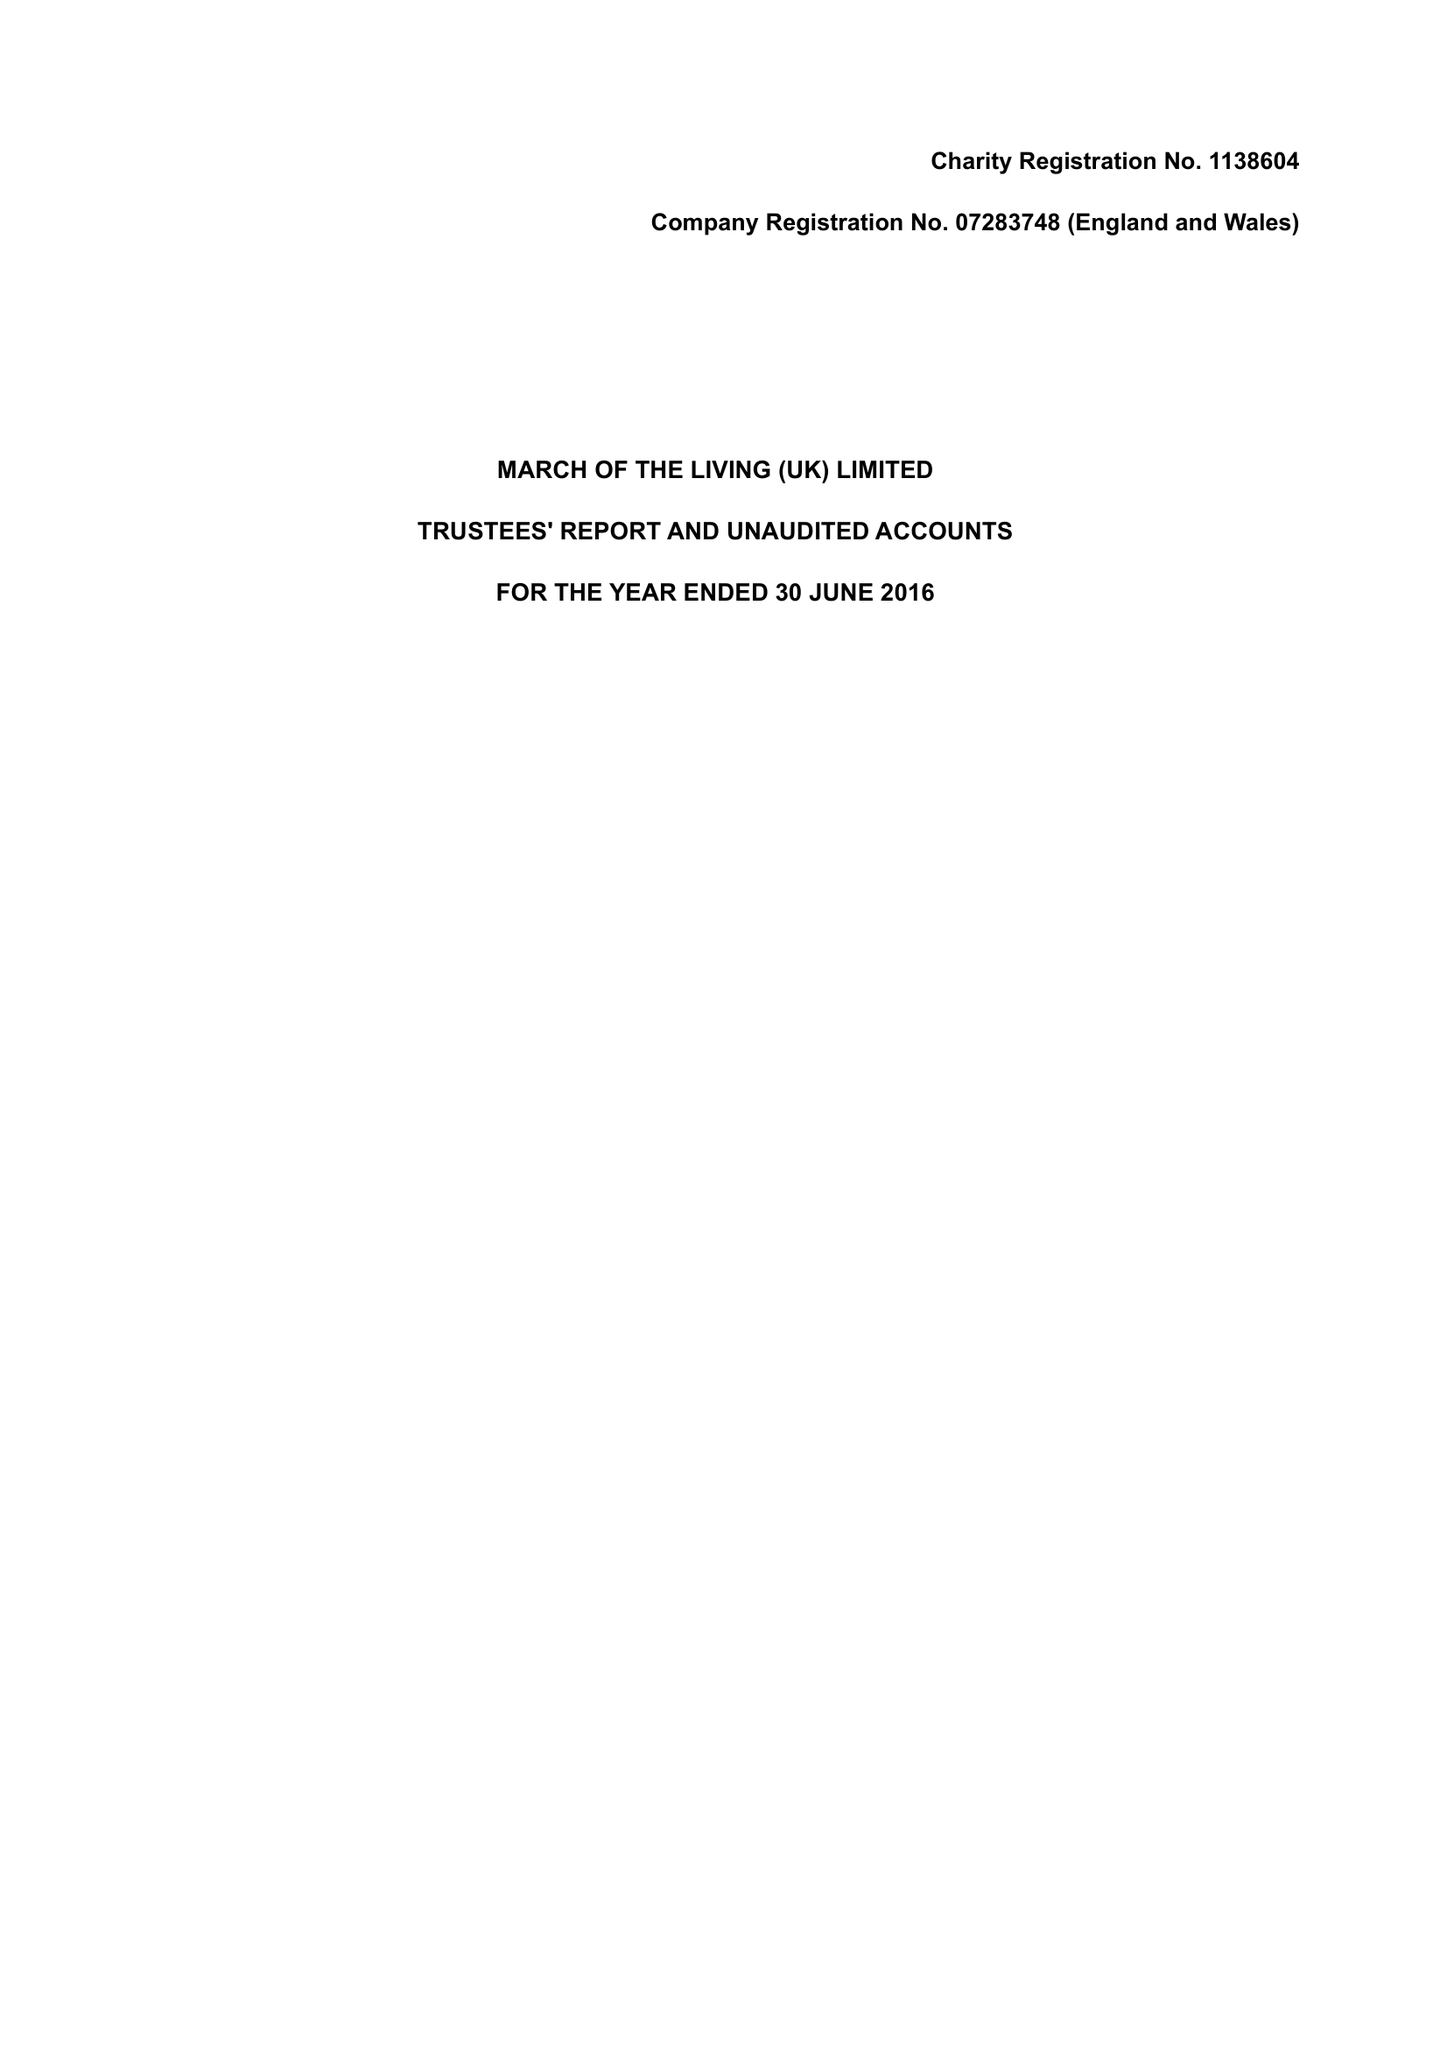What is the value for the report_date?
Answer the question using a single word or phrase. 2016-06-30 